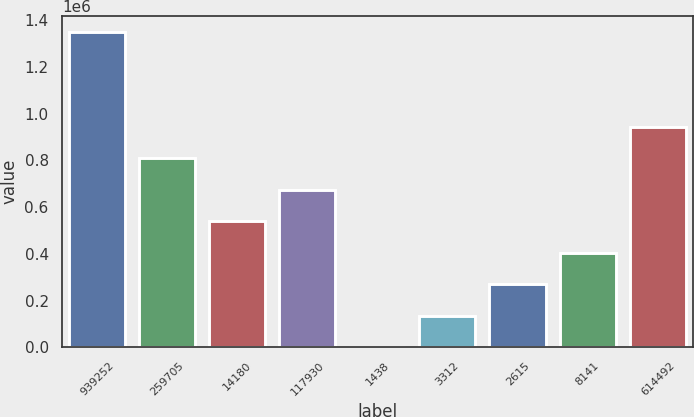Convert chart to OTSL. <chart><loc_0><loc_0><loc_500><loc_500><bar_chart><fcel>939252<fcel>259705<fcel>14180<fcel>117930<fcel>1438<fcel>3312<fcel>2615<fcel>8141<fcel>614492<nl><fcel>1.35046e+06<fcel>810289<fcel>540201<fcel>675245<fcel>24.33<fcel>135068<fcel>270112<fcel>405157<fcel>945333<nl></chart> 